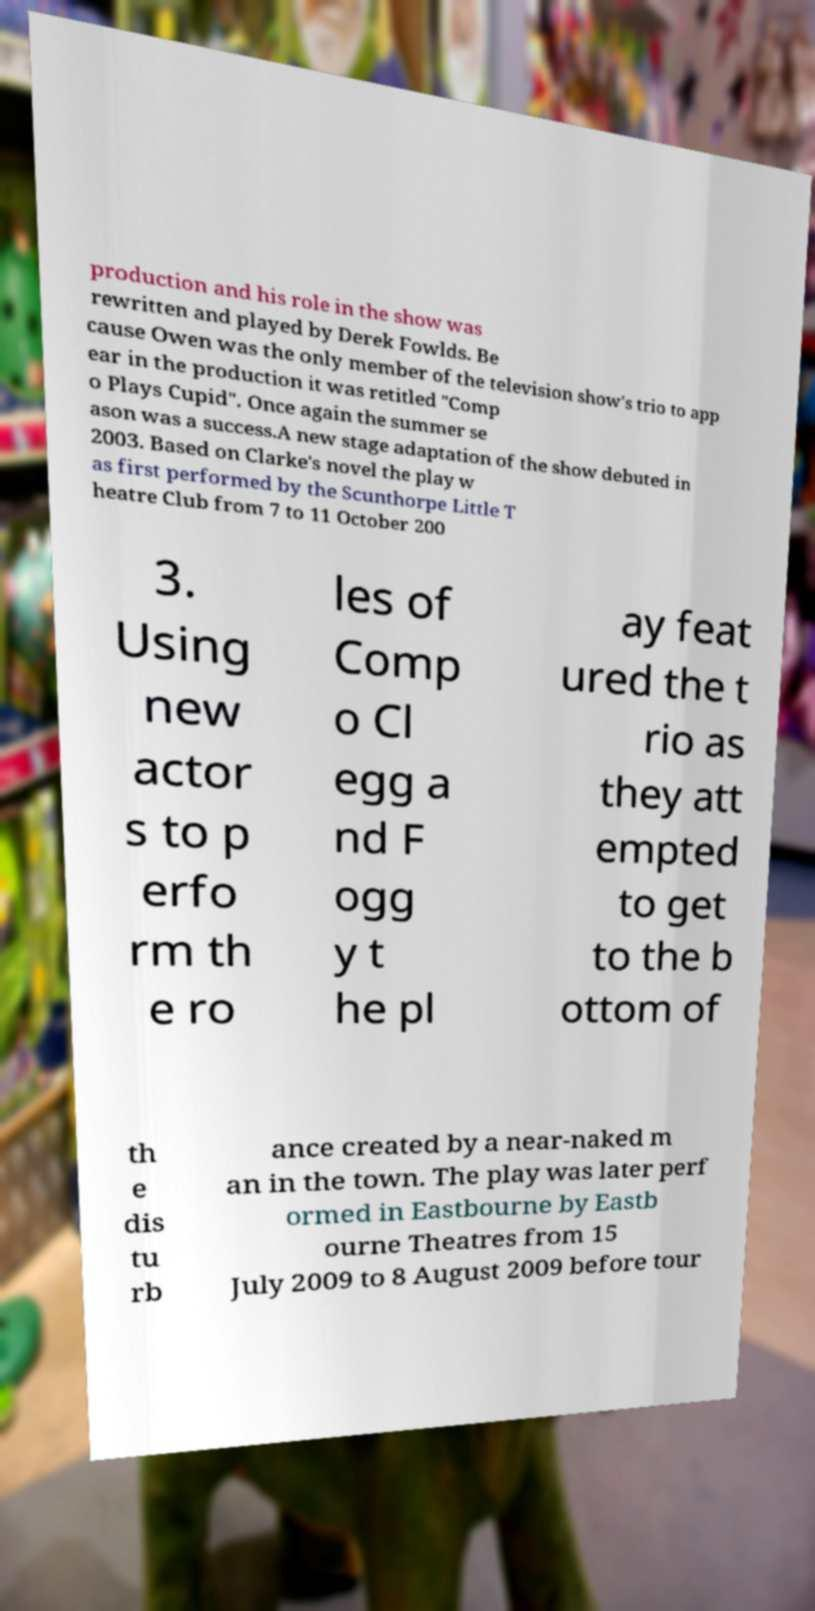Can you read and provide the text displayed in the image?This photo seems to have some interesting text. Can you extract and type it out for me? production and his role in the show was rewritten and played by Derek Fowlds. Be cause Owen was the only member of the television show's trio to app ear in the production it was retitled "Comp o Plays Cupid". Once again the summer se ason was a success.A new stage adaptation of the show debuted in 2003. Based on Clarke's novel the play w as first performed by the Scunthorpe Little T heatre Club from 7 to 11 October 200 3. Using new actor s to p erfo rm th e ro les of Comp o Cl egg a nd F ogg y t he pl ay feat ured the t rio as they att empted to get to the b ottom of th e dis tu rb ance created by a near-naked m an in the town. The play was later perf ormed in Eastbourne by Eastb ourne Theatres from 15 July 2009 to 8 August 2009 before tour 